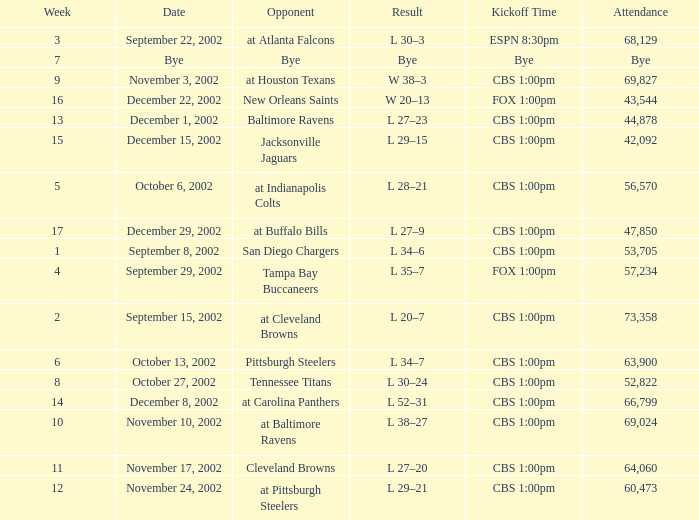Can you give me this table as a dict? {'header': ['Week', 'Date', 'Opponent', 'Result', 'Kickoff Time', 'Attendance'], 'rows': [['3', 'September 22, 2002', 'at Atlanta Falcons', 'L 30–3', 'ESPN 8:30pm', '68,129'], ['7', 'Bye', 'Bye', 'Bye', 'Bye', 'Bye'], ['9', 'November 3, 2002', 'at Houston Texans', 'W 38–3', 'CBS 1:00pm', '69,827'], ['16', 'December 22, 2002', 'New Orleans Saints', 'W 20–13', 'FOX 1:00pm', '43,544'], ['13', 'December 1, 2002', 'Baltimore Ravens', 'L 27–23', 'CBS 1:00pm', '44,878'], ['15', 'December 15, 2002', 'Jacksonville Jaguars', 'L 29–15', 'CBS 1:00pm', '42,092'], ['5', 'October 6, 2002', 'at Indianapolis Colts', 'L 28–21', 'CBS 1:00pm', '56,570'], ['17', 'December 29, 2002', 'at Buffalo Bills', 'L 27–9', 'CBS 1:00pm', '47,850'], ['1', 'September 8, 2002', 'San Diego Chargers', 'L 34–6', 'CBS 1:00pm', '53,705'], ['4', 'September 29, 2002', 'Tampa Bay Buccaneers', 'L 35–7', 'FOX 1:00pm', '57,234'], ['2', 'September 15, 2002', 'at Cleveland Browns', 'L 20–7', 'CBS 1:00pm', '73,358'], ['6', 'October 13, 2002', 'Pittsburgh Steelers', 'L 34–7', 'CBS 1:00pm', '63,900'], ['8', 'October 27, 2002', 'Tennessee Titans', 'L 30–24', 'CBS 1:00pm', '52,822'], ['14', 'December 8, 2002', 'at Carolina Panthers', 'L 52–31', 'CBS 1:00pm', '66,799'], ['10', 'November 10, 2002', 'at Baltimore Ravens', 'L 38–27', 'CBS 1:00pm', '69,024'], ['11', 'November 17, 2002', 'Cleveland Browns', 'L 27–20', 'CBS 1:00pm', '64,060'], ['12', 'November 24, 2002', 'at Pittsburgh Steelers', 'L 29–21', 'CBS 1:00pm', '60,473']]} What is the kickoff time for the game in week of 17? CBS 1:00pm. 